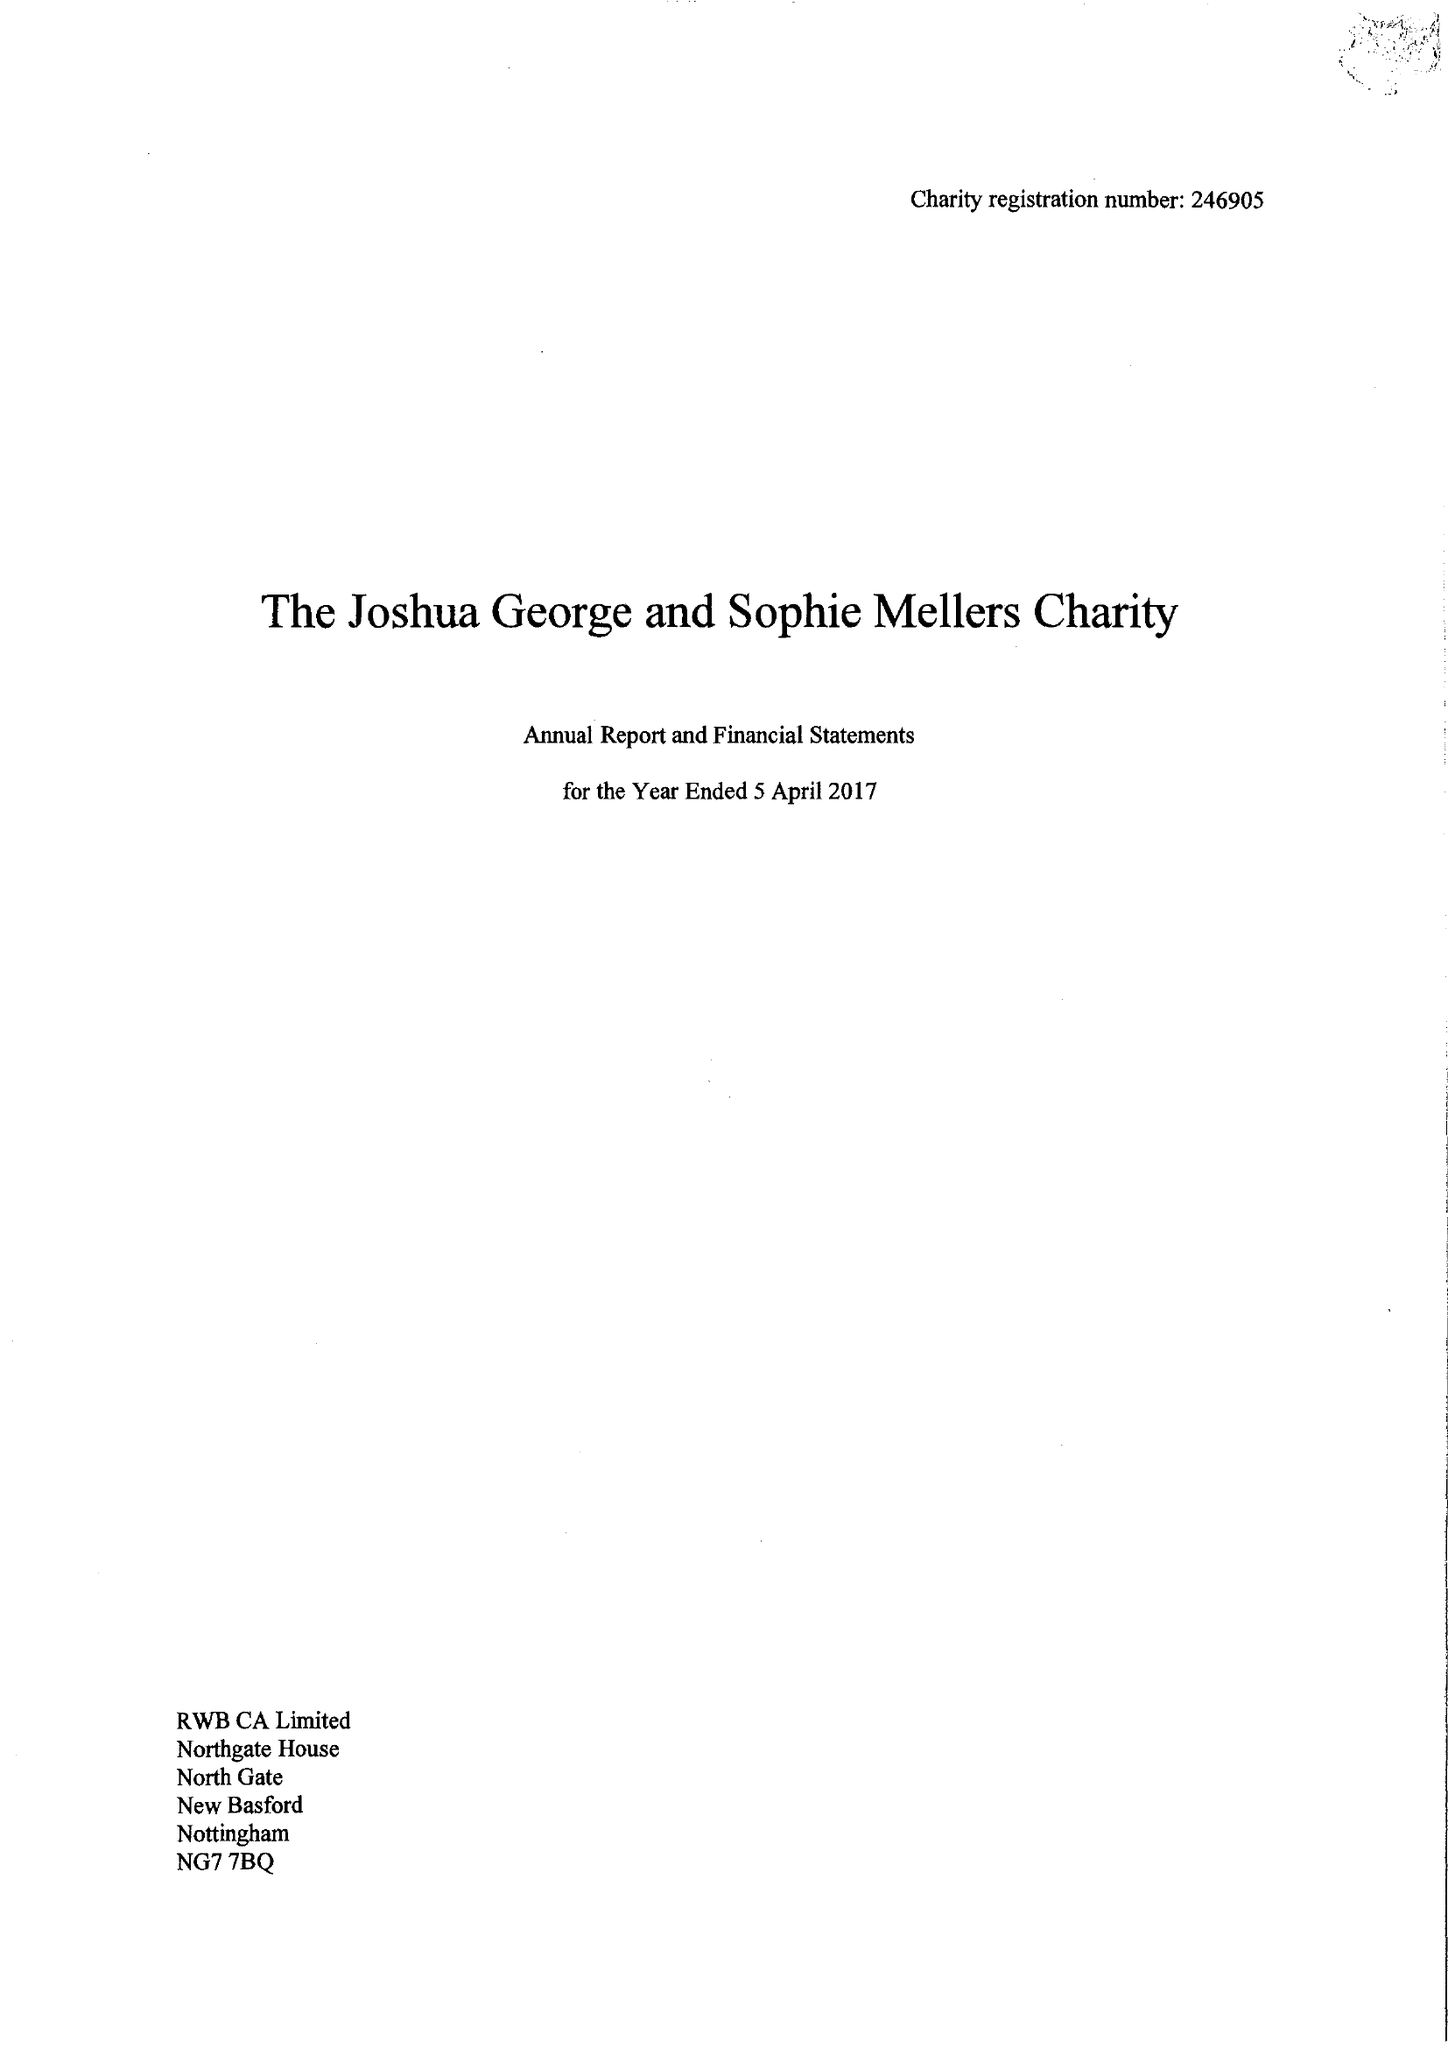What is the value for the report_date?
Answer the question using a single word or phrase. 2017-04-05 